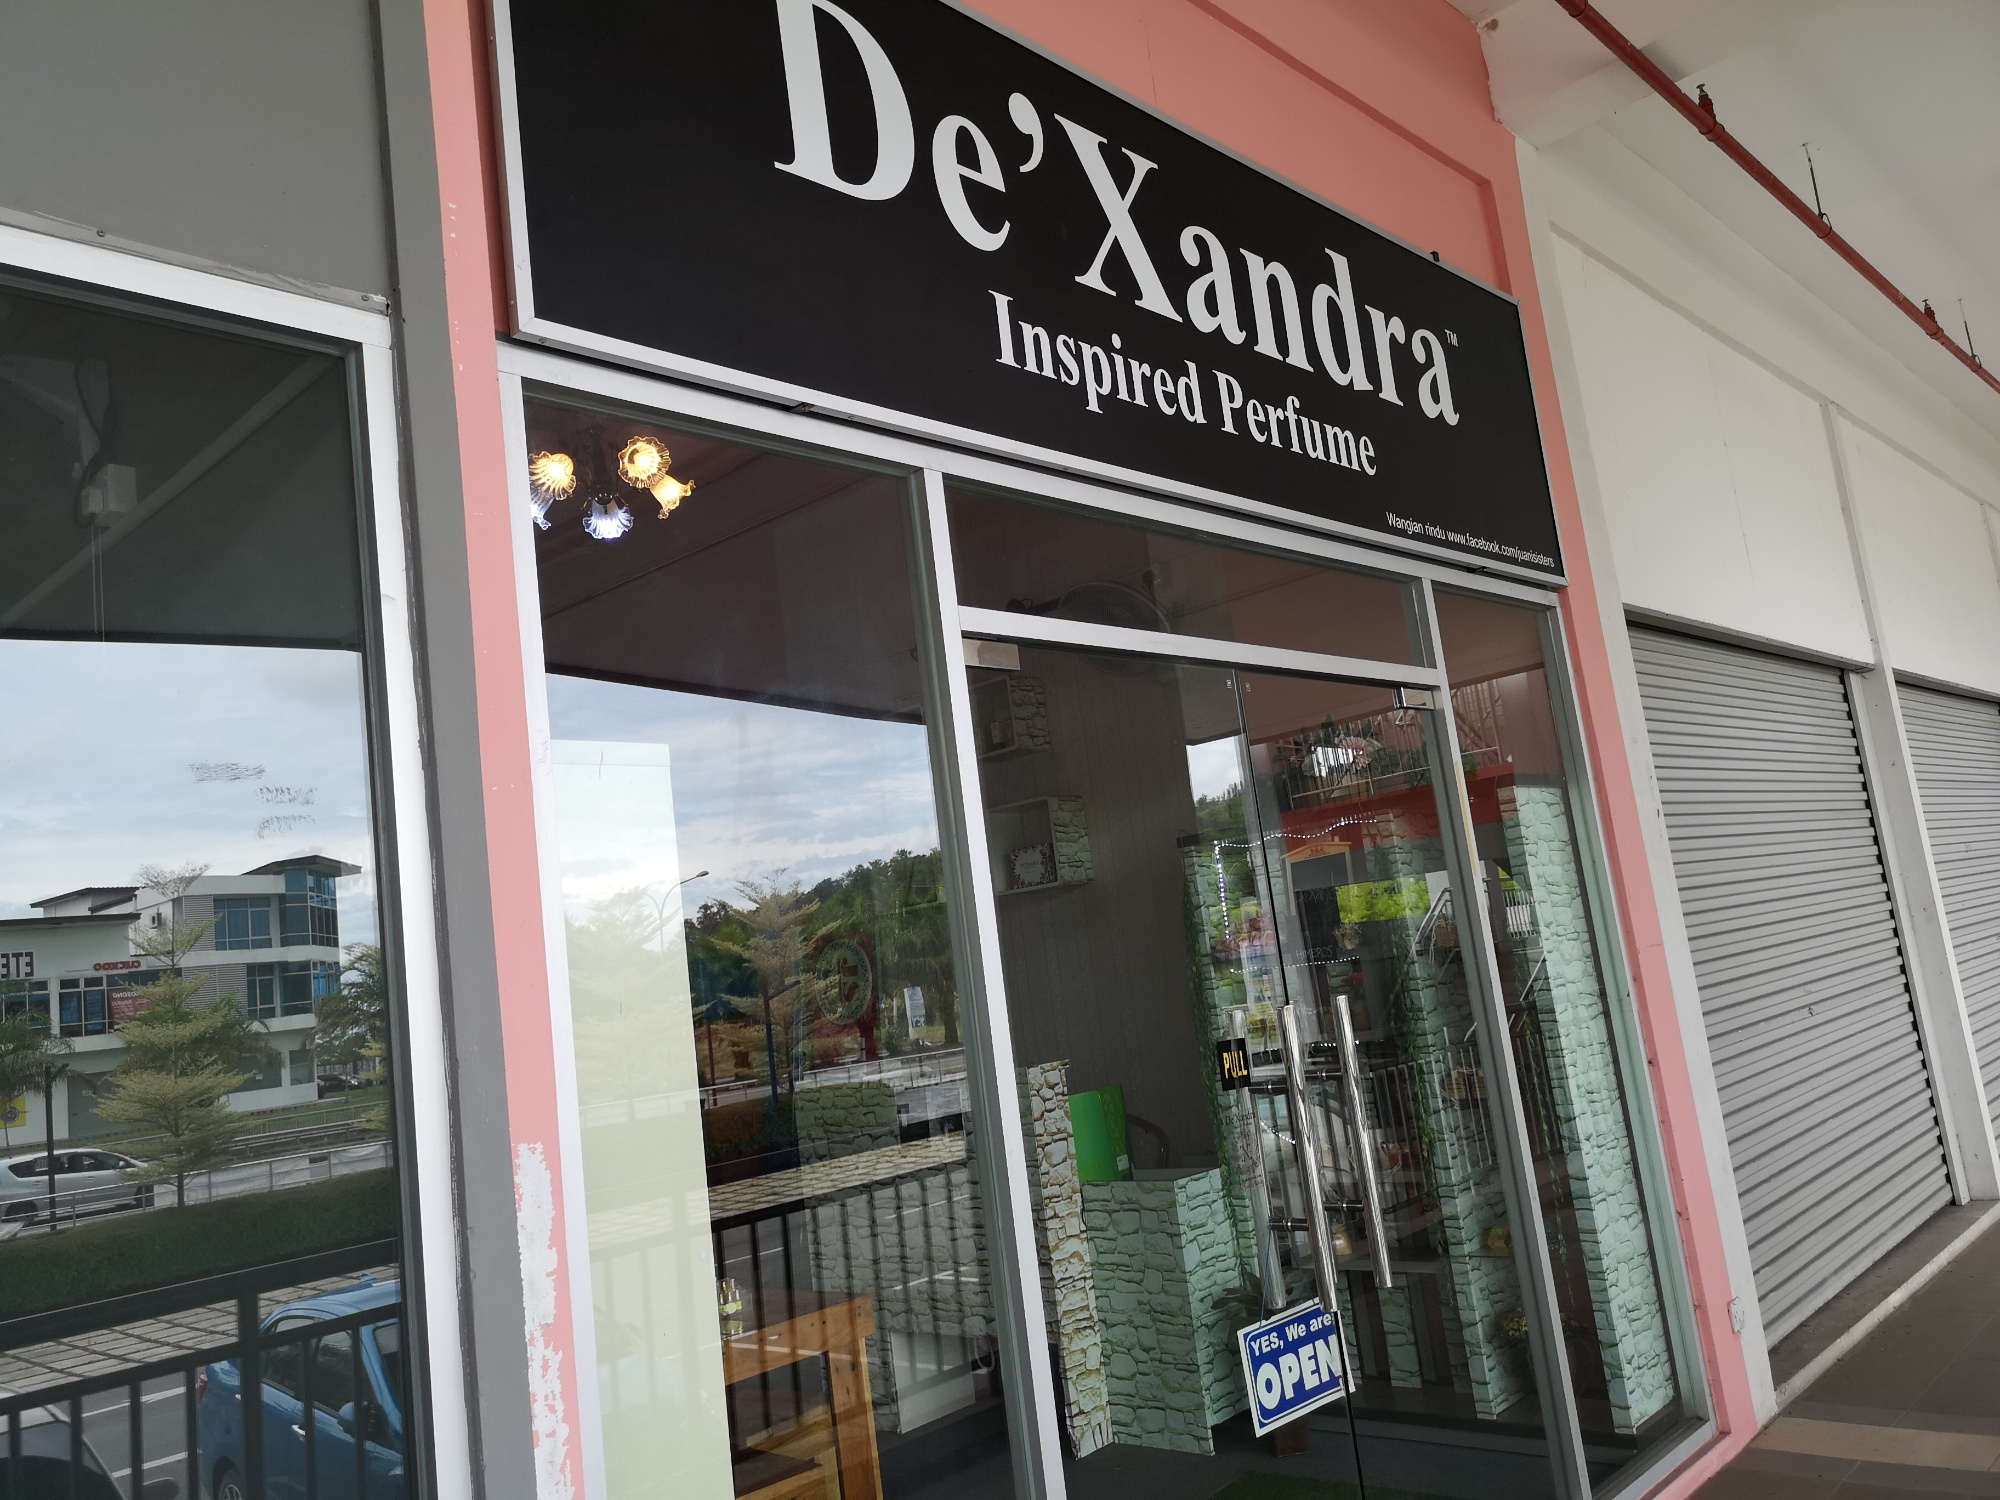How would a typical weekday morning look outside this store? On a typical weekday morning, the scene outside De'Xandra Inspired Perfume would be quite serene. The surrounding parking lot might have a few cars parked as early shoppers begin their day. Birds chirp in the nearby trees while the sun casts a gentle light on the store’s glass facade. Passersby might take a curious glance at the inviting ‘OPEN’ sign, considering stepping in to explore. The overall atmosphere would be calm, peaceful, and perfect for a leisurely start to the day. 